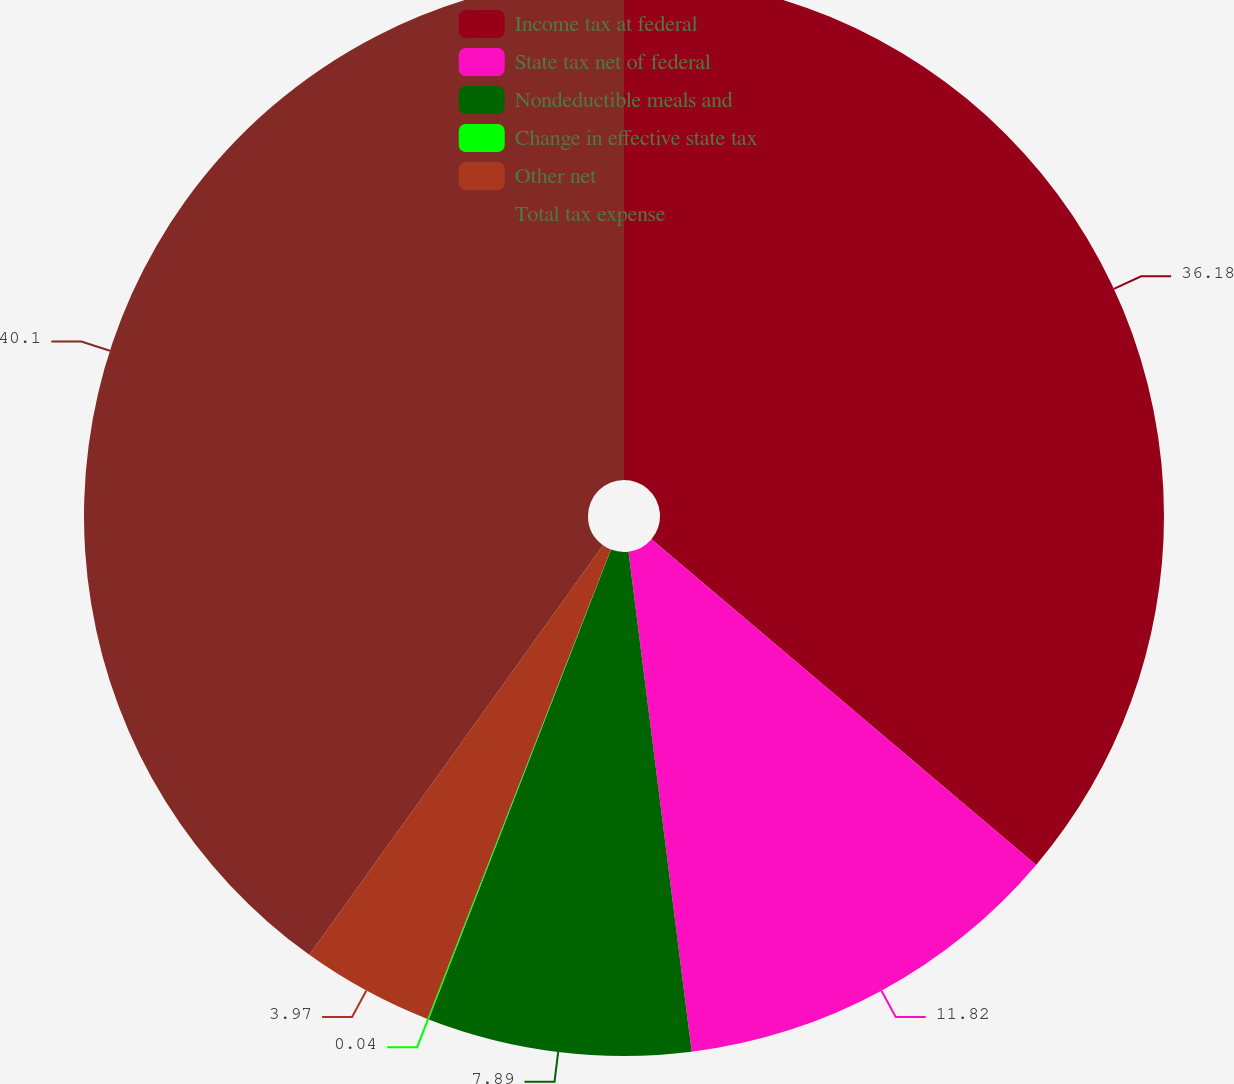<chart> <loc_0><loc_0><loc_500><loc_500><pie_chart><fcel>Income tax at federal<fcel>State tax net of federal<fcel>Nondeductible meals and<fcel>Change in effective state tax<fcel>Other net<fcel>Total tax expense<nl><fcel>36.18%<fcel>11.82%<fcel>7.89%<fcel>0.04%<fcel>3.97%<fcel>40.1%<nl></chart> 